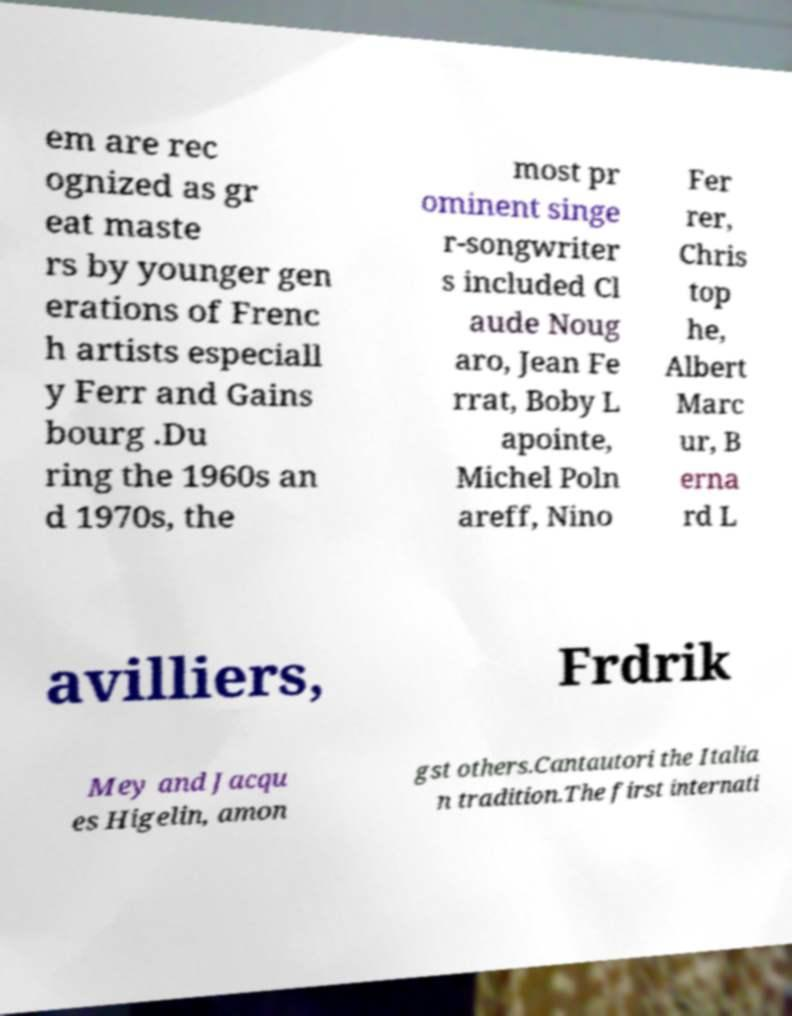Could you assist in decoding the text presented in this image and type it out clearly? em are rec ognized as gr eat maste rs by younger gen erations of Frenc h artists especiall y Ferr and Gains bourg .Du ring the 1960s an d 1970s, the most pr ominent singe r-songwriter s included Cl aude Noug aro, Jean Fe rrat, Boby L apointe, Michel Poln areff, Nino Fer rer, Chris top he, Albert Marc ur, B erna rd L avilliers, Frdrik Mey and Jacqu es Higelin, amon gst others.Cantautori the Italia n tradition.The first internati 